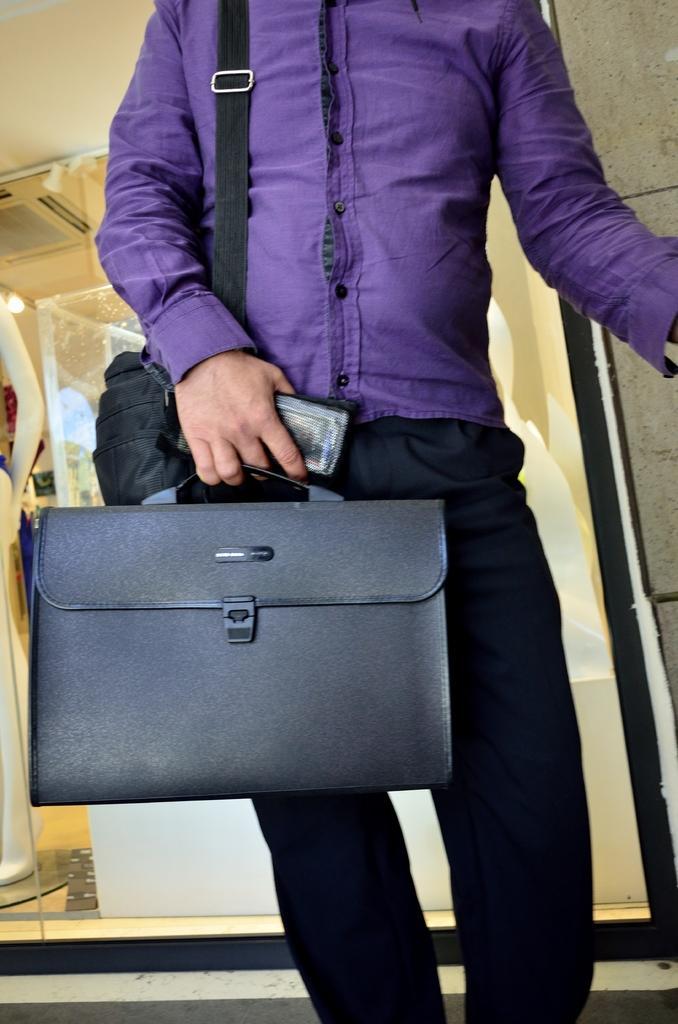In one or two sentences, can you explain what this image depicts? This man wore purple shirt, bag and holding a mobile and suitcase. On top there is a light. We can able to see a mannequin. 